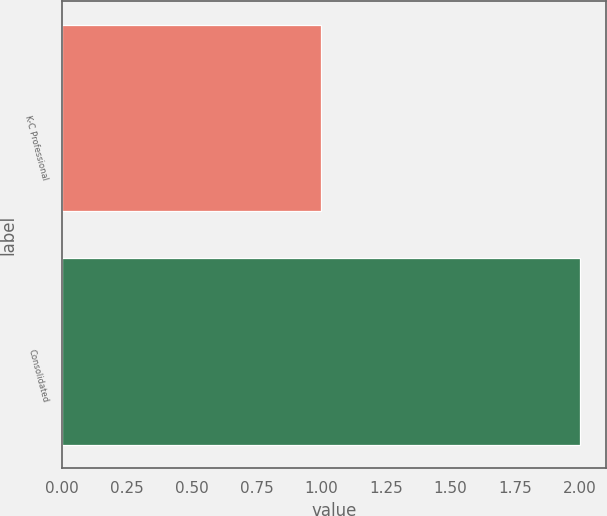<chart> <loc_0><loc_0><loc_500><loc_500><bar_chart><fcel>K-C Professional<fcel>Consolidated<nl><fcel>1<fcel>2<nl></chart> 